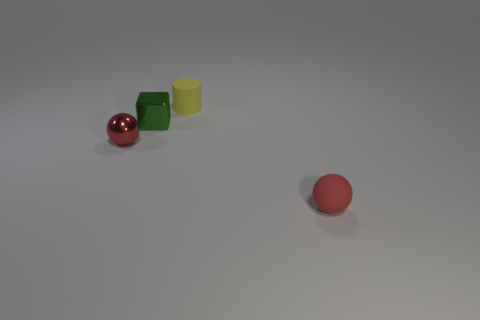How many green matte objects are there?
Your answer should be compact. 0. How big is the rubber object that is behind the small red rubber thing?
Ensure brevity in your answer.  Small. Do the green metallic cube and the rubber cylinder have the same size?
Provide a short and direct response. Yes. What number of objects are big purple metallic blocks or tiny red things that are left of the yellow cylinder?
Provide a succinct answer. 1. What is the tiny cylinder made of?
Your answer should be very brief. Rubber. Is there any other thing that has the same color as the tiny matte sphere?
Offer a very short reply. Yes. Do the small red metal thing and the small red rubber thing have the same shape?
Offer a terse response. Yes. What size is the sphere that is to the left of the tiny red thing in front of the red ball left of the green object?
Your response must be concise. Small. What number of other objects are there of the same material as the yellow cylinder?
Your answer should be compact. 1. What color is the matte thing behind the tiny red rubber object?
Your response must be concise. Yellow. 